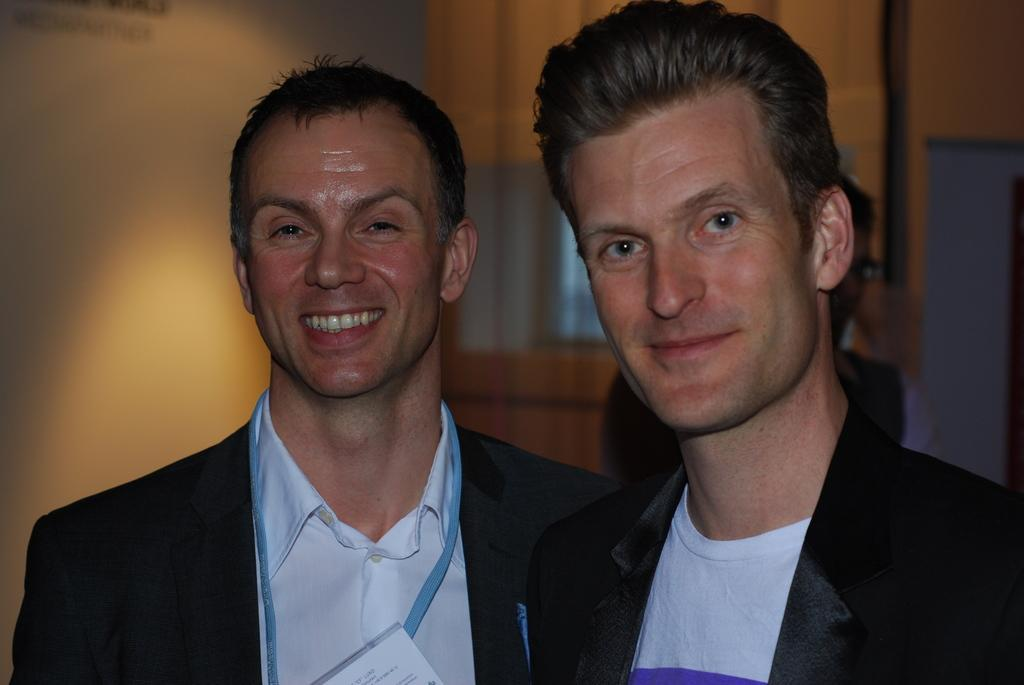How many people are in the image? There are two persons in the image. What are the people wearing? Both persons are wearing black blazers and white shirts. What can be seen in the background of the image? There is a wooden wall in the background of the image. What is the color of the wooden wall? The wooden wall is brown in color. What new idea did the persons come up with during their meeting in the image? There is no indication in the image that the persons are in a meeting or discussing any ideas. --- Facts: 1. There is a car in the image. 2. The car is red. 3. The car has four wheels. 4. There is a road in the image. 5. The road is paved. Absurd Topics: dance, ocean, bird Conversation: What is the main subject of the image? The main subject of the image is a car. What color is the car? The car is red. How many wheels does the car have? The car has four wheels. What can be seen in the background of the image? There is a road in the image. What is the condition of the road? The road is paved. Reasoning: Let's think step by step by step in order to produce the conversation. We start by identifying the main subject of the image, which is the car. Then, we describe specific features of the car, such as its color and the number of wheels. Next, we observe the background of the image, noting that there is a road. Finally, we describe the condition of the road, mentioning that it is paved. Absurd Question/Answer: Can you see any birds flying over the ocean in the image? There is no ocean or birds present in the image; it features a red car and a paved road. 